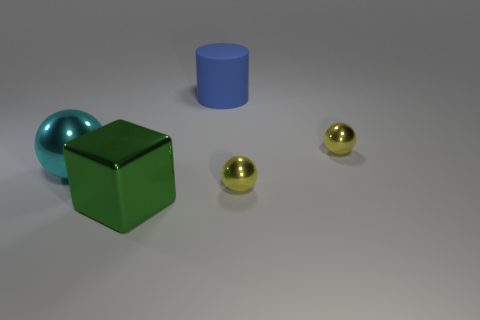Add 2 big balls. How many objects exist? 7 Subtract all cylinders. How many objects are left? 4 Add 5 big green shiny things. How many big green shiny things are left? 6 Add 3 big matte blocks. How many big matte blocks exist? 3 Subtract 0 gray blocks. How many objects are left? 5 Subtract all big purple shiny balls. Subtract all green things. How many objects are left? 4 